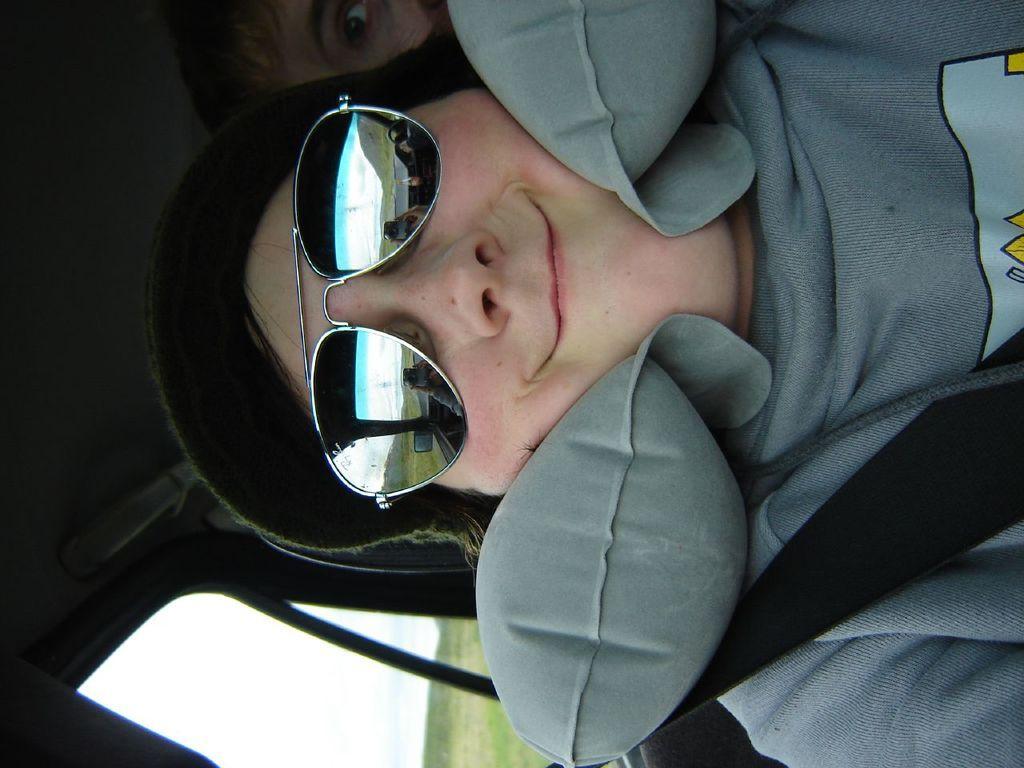How would you summarize this image in a sentence or two? In this image there is a man sitting in a car wearing, glasses and a hat, in the background there is a man. 